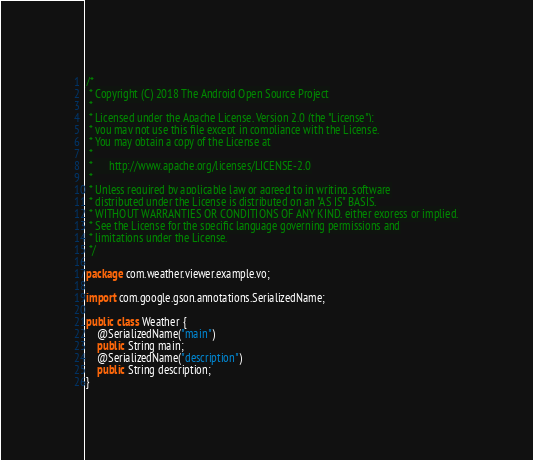Convert code to text. <code><loc_0><loc_0><loc_500><loc_500><_Java_>/*
 * Copyright (C) 2018 The Android Open Source Project
 *
 * Licensed under the Apache License, Version 2.0 (the "License");
 * you may not use this file except in compliance with the License.
 * You may obtain a copy of the License at
 *
 *      http://www.apache.org/licenses/LICENSE-2.0
 *
 * Unless required by applicable law or agreed to in writing, software
 * distributed under the License is distributed on an "AS IS" BASIS,
 * WITHOUT WARRANTIES OR CONDITIONS OF ANY KIND, either express or implied.
 * See the License for the specific language governing permissions and
 * limitations under the License.
 */

package com.weather.viewer.example.vo;

import com.google.gson.annotations.SerializedName;

public class Weather {
    @SerializedName("main")
    public String main;
    @SerializedName("description")
    public String description;
}
</code> 